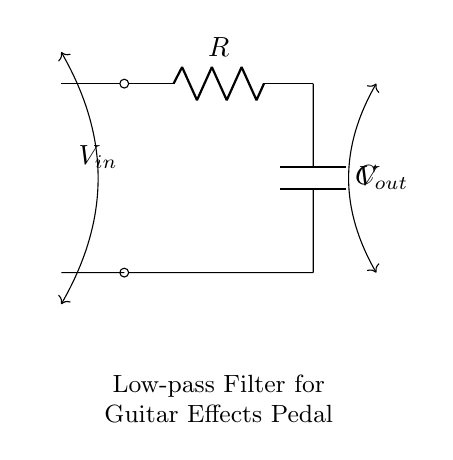What components are present in this circuit? The circuit diagram shows a resistor and a capacitor connected in series, which are the basic components of a low-pass filter.
Answer: Resistor and capacitor What is the function of the capacitor in this filter? The capacitor stores and releases energy, allowing low-frequency signals to pass while blocking higher-frequency signals, thus smoothing out distortion.
Answer: Smoothing distortion What is the output voltage denoted as in the diagram? The output voltage is represented by the symbol V out, which is measured across the capacitor, indicating the filtered signal.
Answer: V out How are the resistor and capacitor connected in this circuit? The resistor is connected in series with the capacitor, allowing current to flow through both components sequentially, which is characteristic of a low-pass filter configuration.
Answer: In series What is the primary effect of this low-pass filter on a guitar signal? The primary effect is the attenuation of high-frequency noise and distortion, which enhances the overall sound quality of the guitar signal when processed through effects pedals.
Answer: Attenuation of high frequencies What happens to high-frequency signals in this circuit? High-frequency signals are blocked by the capacitor, preventing them from passing to the output, which allows only low-frequency signals to emerge, achieving the filtering effect.
Answer: Blocked What type of circuit is represented by this diagram? This diagram represents a low-pass filter circuit, which is specifically designed to allow low-frequency signals to pass while attenuating higher frequencies.
Answer: Low-pass filter 